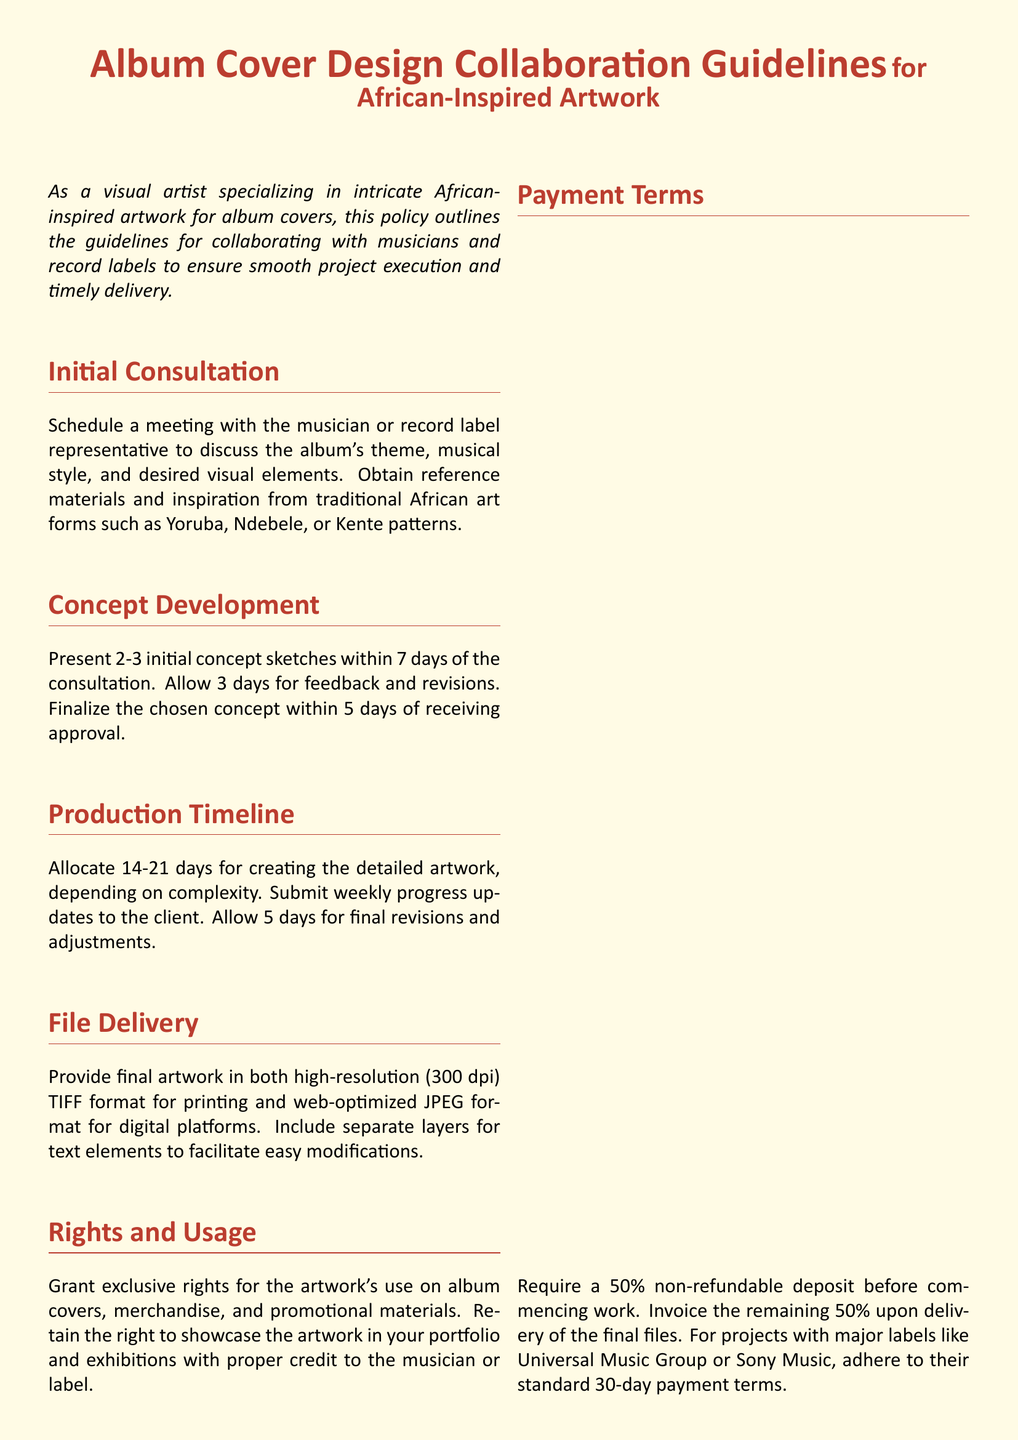What is the title of the document? The title of the document is stated at the top in large font as the main heading.
Answer: Album Cover Design Collaboration Guidelines What are the initial consultation requirements? The requirements for initial consultation involve scheduling a meeting and obtaining reference materials.
Answer: Schedule a meeting What is the maximum number of concept sketches to be presented? The maximum number of initial concept sketches specified in the document is mentioned clearly in one section.
Answer: 3 What is the file format for delivering final artwork? The document specifies the required formats for final artwork delivery mentioned in the relevant section.
Answer: TIFF and JPEG How many days are allocated for creating detailed artwork? The number of days mentioned for creating detailed artwork ranges, which is specified in the Production Timeline section.
Answer: 14-21 What is the non-refundable deposit percentage required before starting work? The percentage for the non-refundable deposit is clearly stated in the Payment Terms section of the document.
Answer: 50% What is the final revisions duration allowed? The duration for final revisions is mentioned explicitly in one of the sections focused on production.
Answer: 5 days Which art forms should inspiration be drawn from? The document specifies particular traditional art forms from which inspiration should be derived, as mentioned in the Initial Consultation section.
Answer: Yoruba, Ndebele, Kente What is the exclusive right regarding the artwork? The exclusive right statement is provided in the Rights and Usage section of the document regarding the artist's rights.
Answer: Use on album covers What is the payment term for major labels? The term for payments specified in relation to major labels is outlined in the Payment Terms section.
Answer: 30-day payment terms 